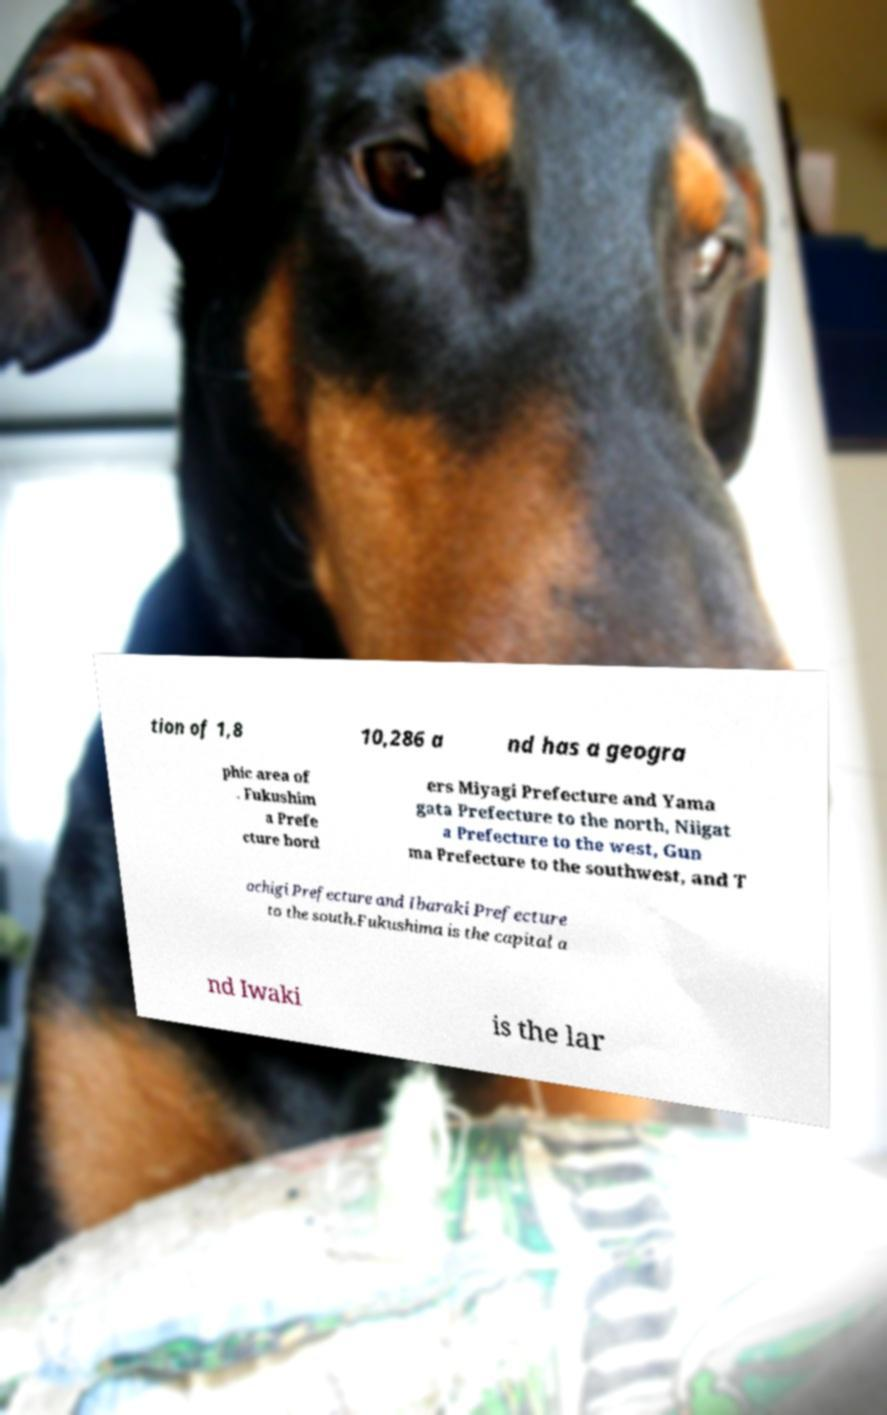Could you assist in decoding the text presented in this image and type it out clearly? tion of 1,8 10,286 a nd has a geogra phic area of . Fukushim a Prefe cture bord ers Miyagi Prefecture and Yama gata Prefecture to the north, Niigat a Prefecture to the west, Gun ma Prefecture to the southwest, and T ochigi Prefecture and Ibaraki Prefecture to the south.Fukushima is the capital a nd Iwaki is the lar 